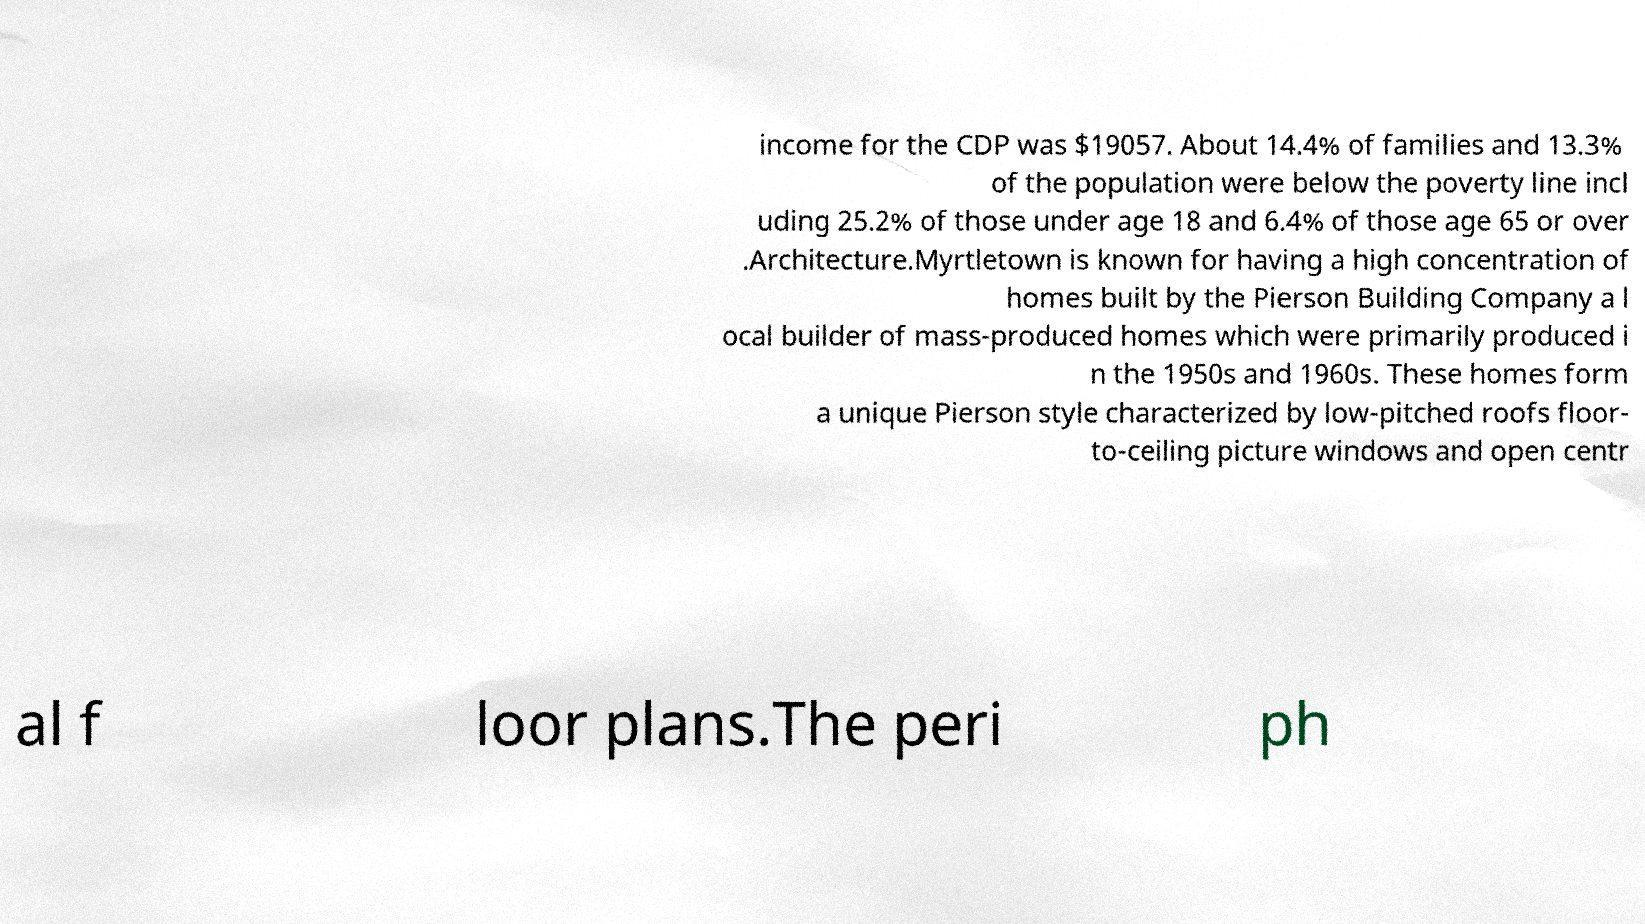Can you accurately transcribe the text from the provided image for me? income for the CDP was $19057. About 14.4% of families and 13.3% of the population were below the poverty line incl uding 25.2% of those under age 18 and 6.4% of those age 65 or over .Architecture.Myrtletown is known for having a high concentration of homes built by the Pierson Building Company a l ocal builder of mass-produced homes which were primarily produced i n the 1950s and 1960s. These homes form a unique Pierson style characterized by low-pitched roofs floor- to-ceiling picture windows and open centr al f loor plans.The peri ph 